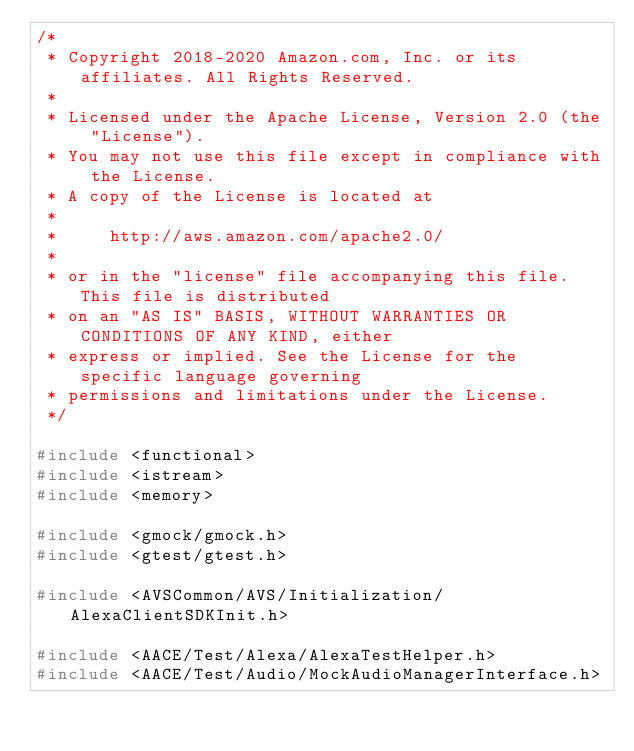<code> <loc_0><loc_0><loc_500><loc_500><_C++_>/*
 * Copyright 2018-2020 Amazon.com, Inc. or its affiliates. All Rights Reserved.
 *
 * Licensed under the Apache License, Version 2.0 (the "License").
 * You may not use this file except in compliance with the License.
 * A copy of the License is located at
 *
 *     http://aws.amazon.com/apache2.0/
 *
 * or in the "license" file accompanying this file. This file is distributed
 * on an "AS IS" BASIS, WITHOUT WARRANTIES OR CONDITIONS OF ANY KIND, either
 * express or implied. See the License for the specific language governing
 * permissions and limitations under the License.
 */

#include <functional>
#include <istream>
#include <memory>

#include <gmock/gmock.h>
#include <gtest/gtest.h>

#include <AVSCommon/AVS/Initialization/AlexaClientSDKInit.h>

#include <AACE/Test/Alexa/AlexaTestHelper.h>
#include <AACE/Test/Audio/MockAudioManagerInterface.h></code> 